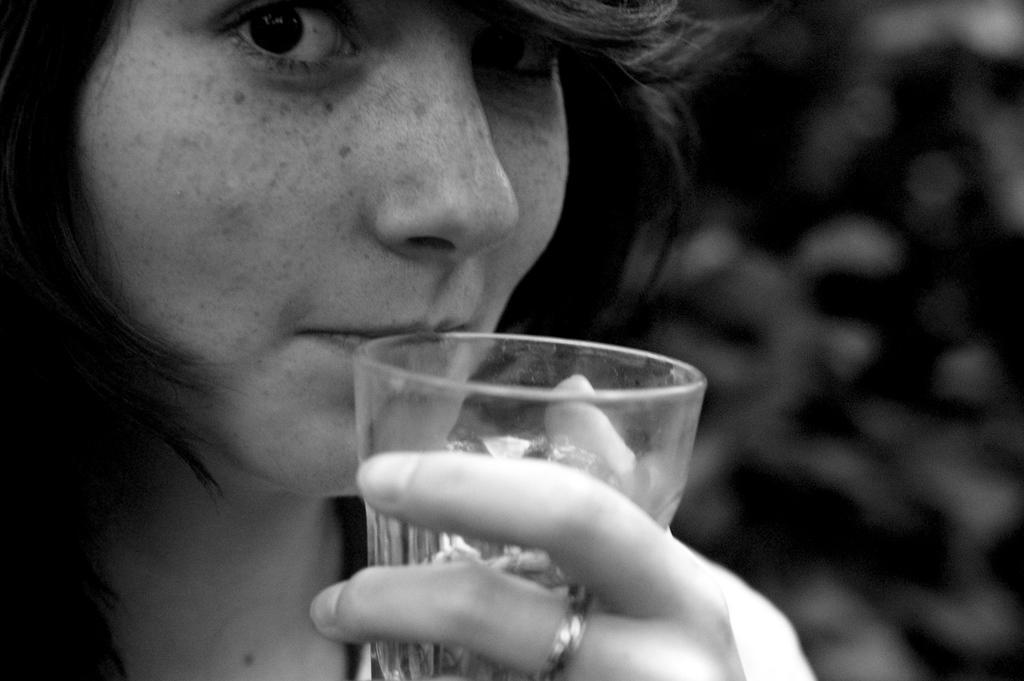Could you give a brief overview of what you see in this image? It is a black and white image. In this image we can see a woman holding the glass and the glass is nearer to her lips. The background of the image is unclear. 